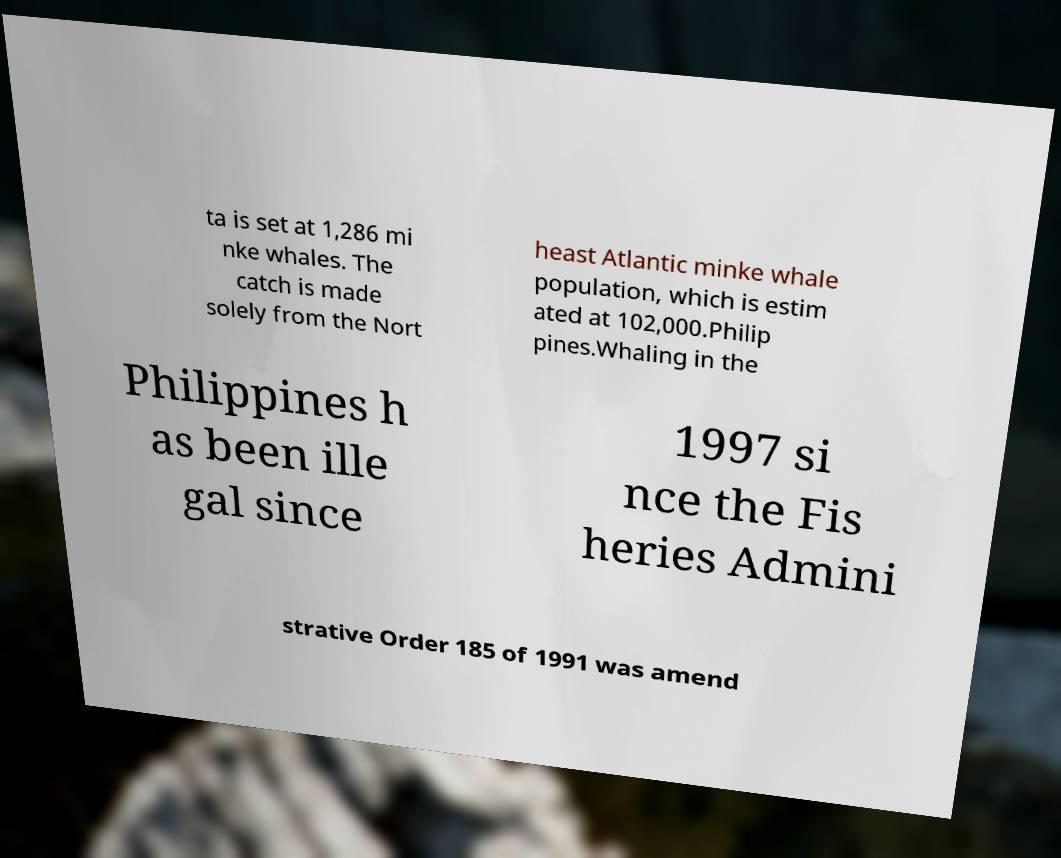Please identify and transcribe the text found in this image. ta is set at 1,286 mi nke whales. The catch is made solely from the Nort heast Atlantic minke whale population, which is estim ated at 102,000.Philip pines.Whaling in the Philippines h as been ille gal since 1997 si nce the Fis heries Admini strative Order 185 of 1991 was amend 